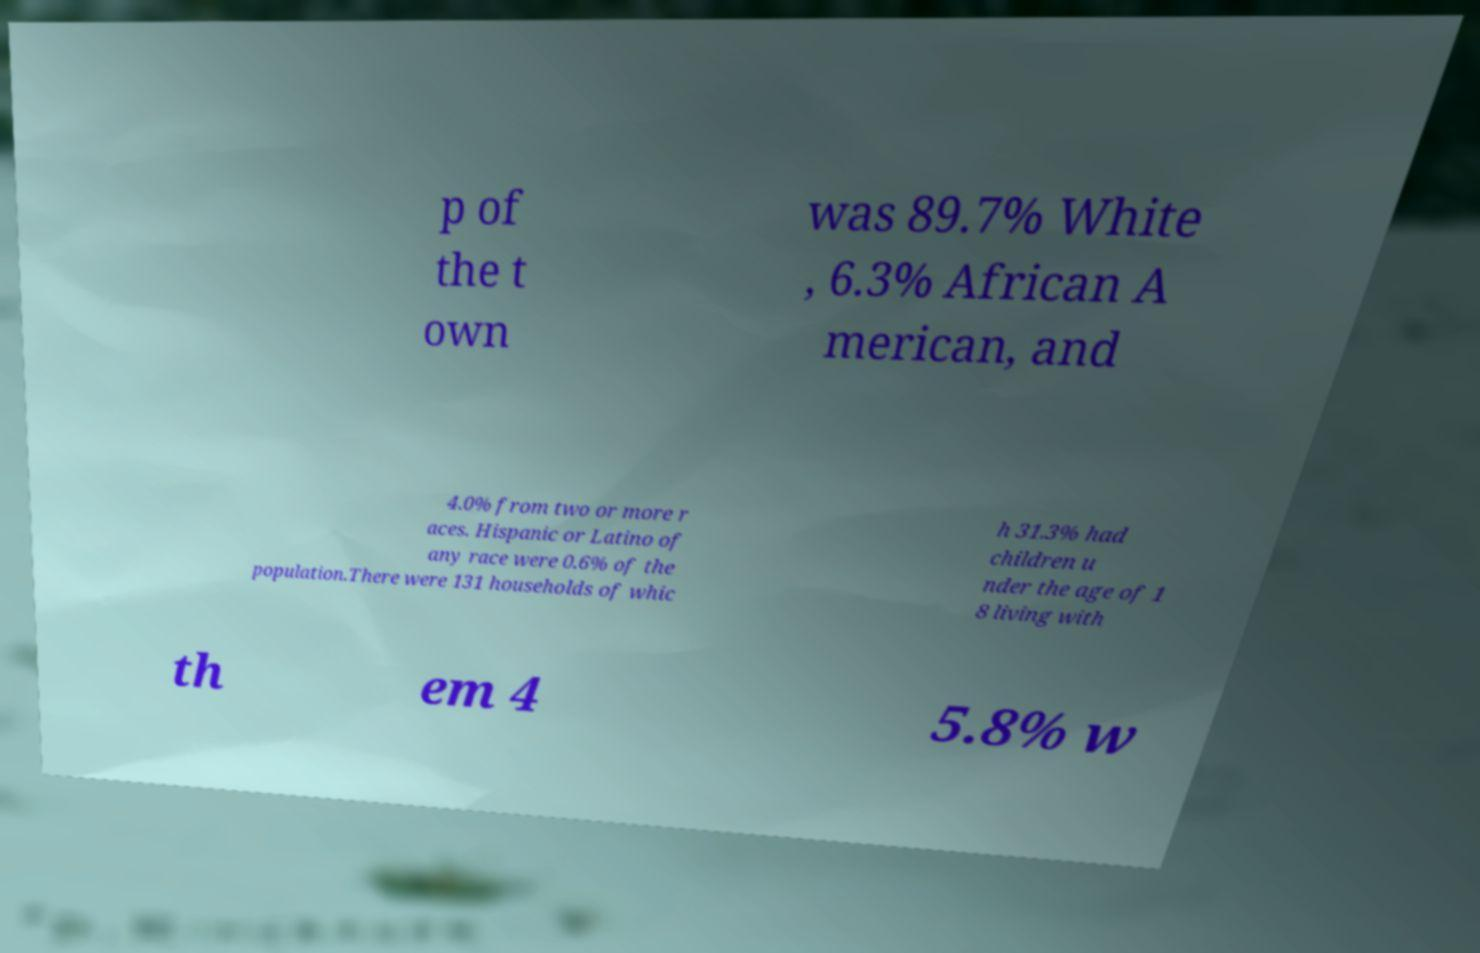Can you accurately transcribe the text from the provided image for me? p of the t own was 89.7% White , 6.3% African A merican, and 4.0% from two or more r aces. Hispanic or Latino of any race were 0.6% of the population.There were 131 households of whic h 31.3% had children u nder the age of 1 8 living with th em 4 5.8% w 